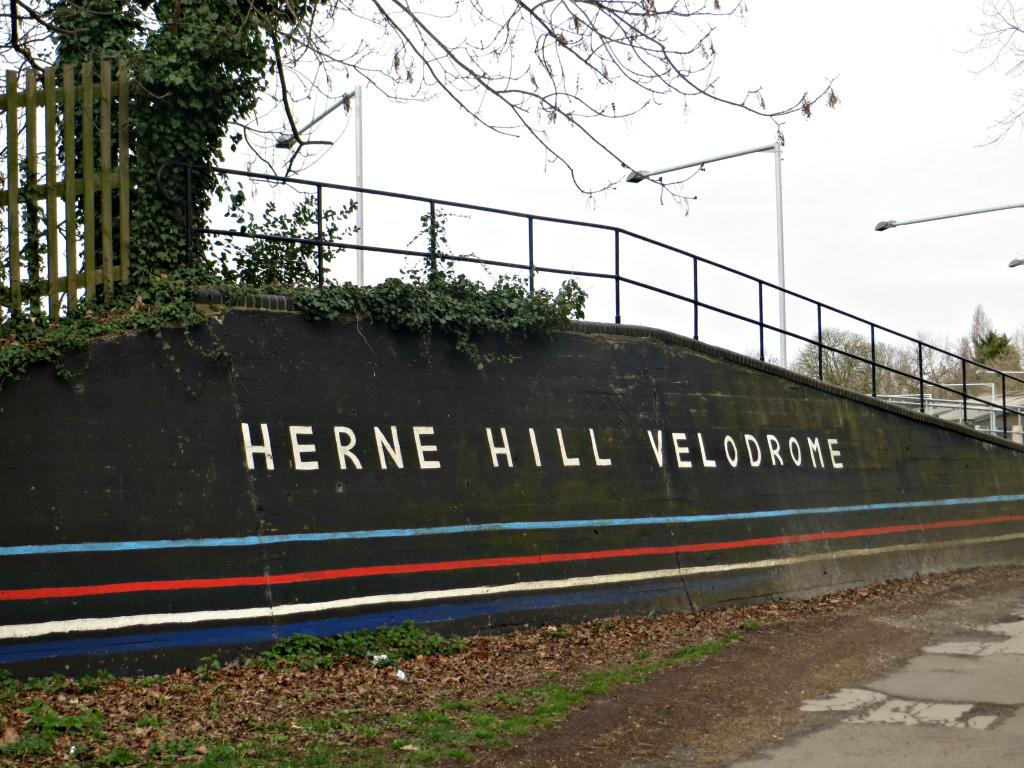Provide a one-sentence caption for the provided image. Words on a hill side annouce Herne Hill Velodrome. 